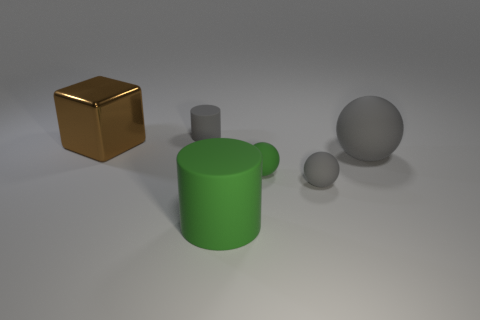What materials might these objects be made of given their appearance? Based on their appearance, the shiny golden brown block could be metallic or plastic with a reflective coating. The matte green cylinder and mug suggest a ceramic or matte-painted surface, while the spheres, one matte gray like stone or dull metal and the other reflective silver, hint at a metallic or reflective plastic composition. 